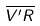Convert formula to latex. <formula><loc_0><loc_0><loc_500><loc_500>\overline { V ^ { \prime } R }</formula> 